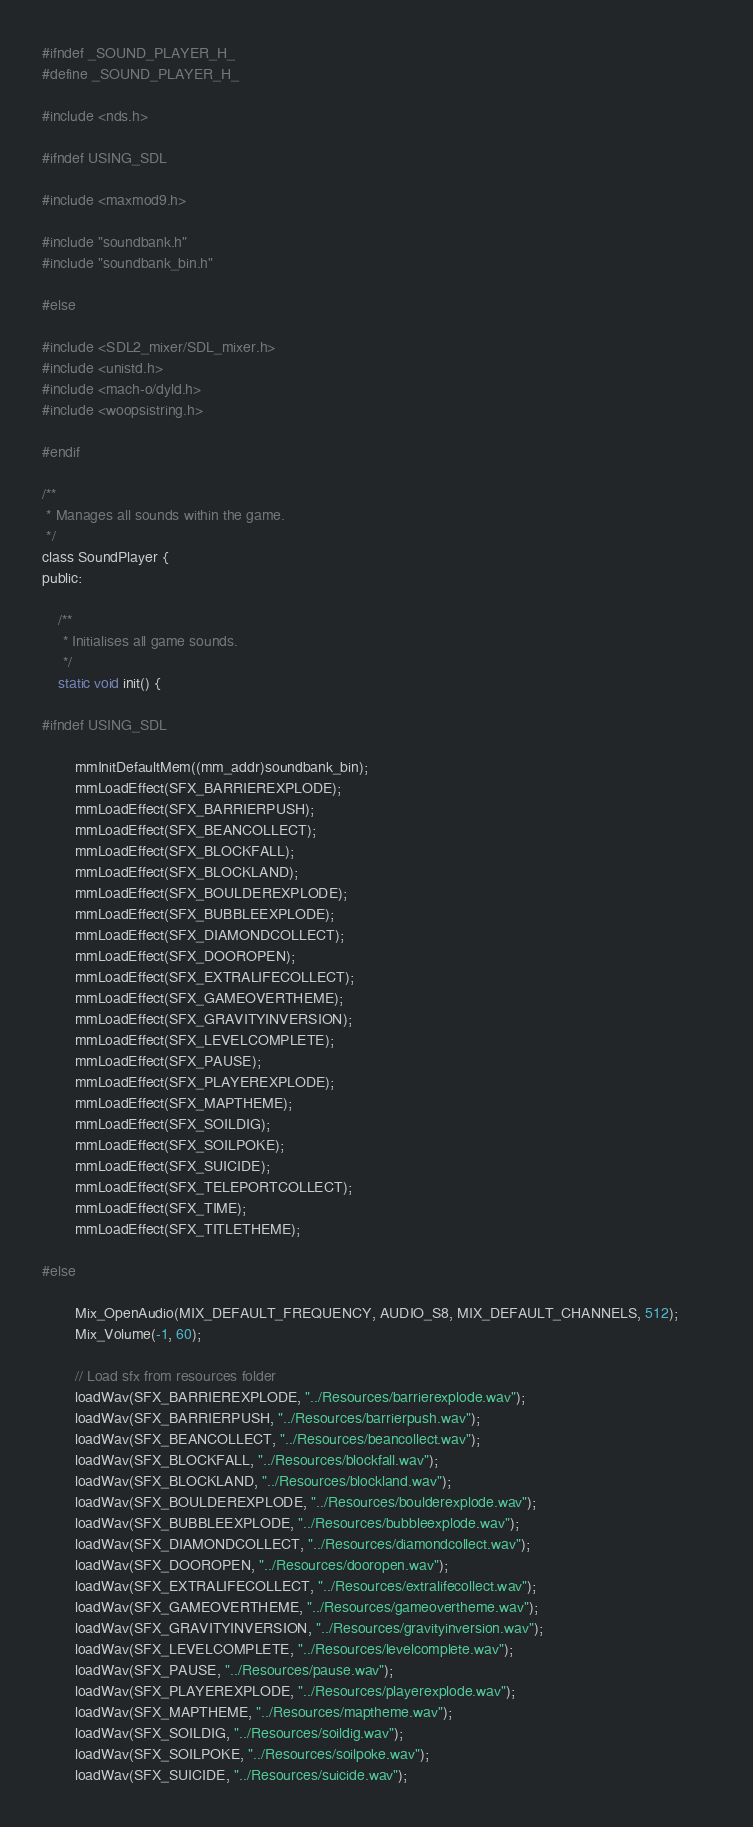Convert code to text. <code><loc_0><loc_0><loc_500><loc_500><_C_>#ifndef _SOUND_PLAYER_H_
#define _SOUND_PLAYER_H_

#include <nds.h>

#ifndef USING_SDL

#include <maxmod9.h>

#include "soundbank.h"
#include "soundbank_bin.h"

#else

#include <SDL2_mixer/SDL_mixer.h>
#include <unistd.h>
#include <mach-o/dyld.h>
#include <woopsistring.h>

#endif

/**
 * Manages all sounds within the game.
 */
class SoundPlayer {
public:

	/**
	 * Initialises all game sounds.
	 */
	static void init() {

#ifndef USING_SDL

		mmInitDefaultMem((mm_addr)soundbank_bin);
		mmLoadEffect(SFX_BARRIEREXPLODE);
		mmLoadEffect(SFX_BARRIERPUSH);
		mmLoadEffect(SFX_BEANCOLLECT);
		mmLoadEffect(SFX_BLOCKFALL);
		mmLoadEffect(SFX_BLOCKLAND);
		mmLoadEffect(SFX_BOULDEREXPLODE);
		mmLoadEffect(SFX_BUBBLEEXPLODE);
		mmLoadEffect(SFX_DIAMONDCOLLECT);
		mmLoadEffect(SFX_DOOROPEN);
		mmLoadEffect(SFX_EXTRALIFECOLLECT);
		mmLoadEffect(SFX_GAMEOVERTHEME);
		mmLoadEffect(SFX_GRAVITYINVERSION);
		mmLoadEffect(SFX_LEVELCOMPLETE);
		mmLoadEffect(SFX_PAUSE);
		mmLoadEffect(SFX_PLAYEREXPLODE);
		mmLoadEffect(SFX_MAPTHEME);
		mmLoadEffect(SFX_SOILDIG);
		mmLoadEffect(SFX_SOILPOKE);
		mmLoadEffect(SFX_SUICIDE);
		mmLoadEffect(SFX_TELEPORTCOLLECT);
		mmLoadEffect(SFX_TIME);
		mmLoadEffect(SFX_TITLETHEME);
		
#else
		
		Mix_OpenAudio(MIX_DEFAULT_FREQUENCY, AUDIO_S8, MIX_DEFAULT_CHANNELS, 512);		
		Mix_Volume(-1, 60);
		
		// Load sfx from resources folder
		loadWav(SFX_BARRIEREXPLODE, "../Resources/barrierexplode.wav");
		loadWav(SFX_BARRIERPUSH, "../Resources/barrierpush.wav");
		loadWav(SFX_BEANCOLLECT, "../Resources/beancollect.wav");
		loadWav(SFX_BLOCKFALL, "../Resources/blockfall.wav");
		loadWav(SFX_BLOCKLAND, "../Resources/blockland.wav");
		loadWav(SFX_BOULDEREXPLODE, "../Resources/boulderexplode.wav");
		loadWav(SFX_BUBBLEEXPLODE, "../Resources/bubbleexplode.wav");
		loadWav(SFX_DIAMONDCOLLECT, "../Resources/diamondcollect.wav");
		loadWav(SFX_DOOROPEN, "../Resources/dooropen.wav");
		loadWav(SFX_EXTRALIFECOLLECT, "../Resources/extralifecollect.wav");
		loadWav(SFX_GAMEOVERTHEME, "../Resources/gameovertheme.wav");
		loadWav(SFX_GRAVITYINVERSION, "../Resources/gravityinversion.wav");
		loadWav(SFX_LEVELCOMPLETE, "../Resources/levelcomplete.wav");
		loadWav(SFX_PAUSE, "../Resources/pause.wav");
		loadWav(SFX_PLAYEREXPLODE, "../Resources/playerexplode.wav");
		loadWav(SFX_MAPTHEME, "../Resources/maptheme.wav");
		loadWav(SFX_SOILDIG, "../Resources/soildig.wav");
		loadWav(SFX_SOILPOKE, "../Resources/soilpoke.wav");
		loadWav(SFX_SUICIDE, "../Resources/suicide.wav");</code> 